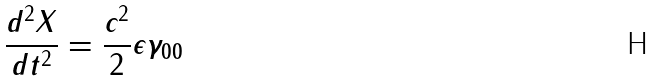Convert formula to latex. <formula><loc_0><loc_0><loc_500><loc_500>\frac { d ^ { 2 } X } { d t ^ { 2 } } = \frac { c ^ { 2 } } { 2 } \epsilon \gamma _ { 0 0 }</formula> 